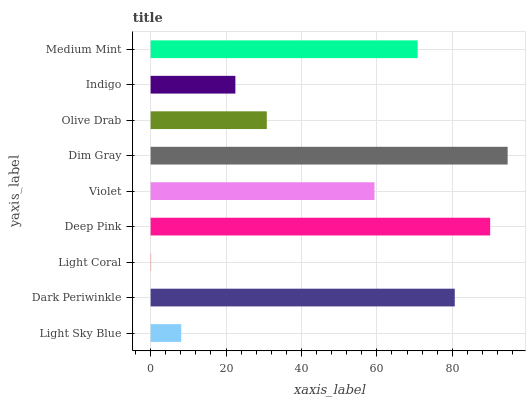Is Light Coral the minimum?
Answer yes or no. Yes. Is Dim Gray the maximum?
Answer yes or no. Yes. Is Dark Periwinkle the minimum?
Answer yes or no. No. Is Dark Periwinkle the maximum?
Answer yes or no. No. Is Dark Periwinkle greater than Light Sky Blue?
Answer yes or no. Yes. Is Light Sky Blue less than Dark Periwinkle?
Answer yes or no. Yes. Is Light Sky Blue greater than Dark Periwinkle?
Answer yes or no. No. Is Dark Periwinkle less than Light Sky Blue?
Answer yes or no. No. Is Violet the high median?
Answer yes or no. Yes. Is Violet the low median?
Answer yes or no. Yes. Is Olive Drab the high median?
Answer yes or no. No. Is Dim Gray the low median?
Answer yes or no. No. 